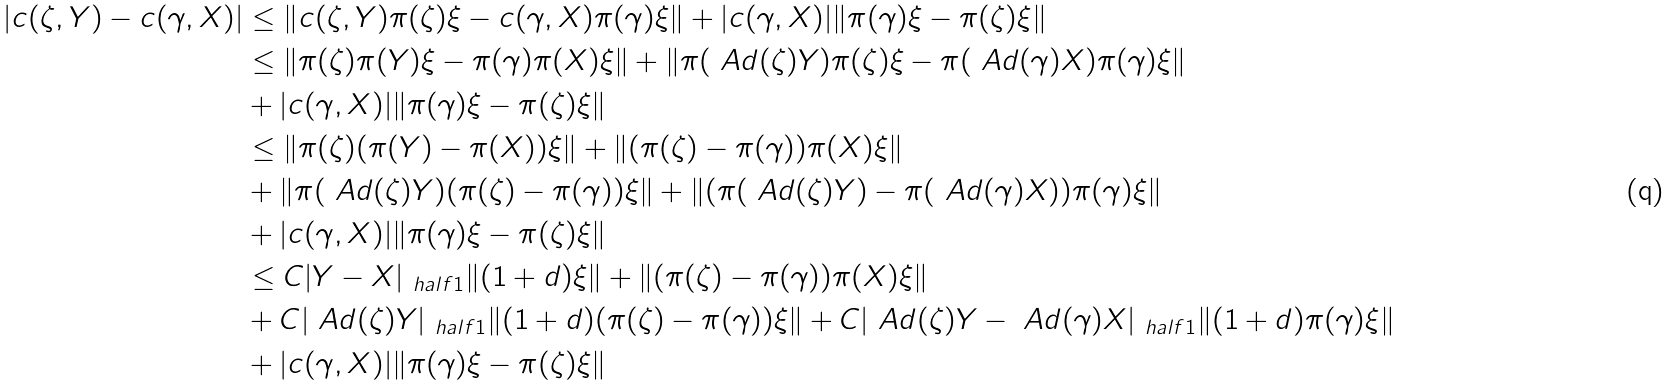<formula> <loc_0><loc_0><loc_500><loc_500>| c ( \zeta , Y ) - c ( \gamma , X ) | & \leq \| c ( \zeta , Y ) \pi ( \zeta ) \xi - c ( \gamma , X ) \pi ( \gamma ) \xi \| + | c ( \gamma , X ) | \| \pi ( \gamma ) \xi - \pi ( \zeta ) \xi \| \\ & \leq \| \pi ( \zeta ) \pi ( Y ) \xi - \pi ( \gamma ) \pi ( X ) \xi \| + \| \pi ( \ A d ( \zeta ) Y ) \pi ( \zeta ) \xi - \pi ( \ A d ( \gamma ) X ) \pi ( \gamma ) \xi \| \\ & + | c ( \gamma , X ) | \| \pi ( \gamma ) \xi - \pi ( \zeta ) \xi \| \\ & \leq \| \pi ( \zeta ) ( \pi ( Y ) - \pi ( X ) ) \xi \| + \| ( \pi ( \zeta ) - \pi ( \gamma ) ) \pi ( X ) \xi \| \\ & + \| \pi ( \ A d ( \zeta ) Y ) ( \pi ( \zeta ) - \pi ( \gamma ) ) \xi \| + \| ( \pi ( \ A d ( \zeta ) Y ) - \pi ( \ A d ( \gamma ) X ) ) \pi ( \gamma ) \xi \| \\ & + | c ( \gamma , X ) | \| \pi ( \gamma ) \xi - \pi ( \zeta ) \xi \| \\ & \leq C | Y - X | _ { \ h a l f { 1 } } \| ( 1 + d ) \xi \| + \| ( \pi ( \zeta ) - \pi ( \gamma ) ) \pi ( X ) \xi \| \\ & + C | \ A d ( \zeta ) Y | _ { \ h a l f { 1 } } \| ( 1 + d ) ( \pi ( \zeta ) - \pi ( \gamma ) ) \xi \| + C | \ A d ( \zeta ) Y - \ A d ( \gamma ) X | _ { \ h a l f { 1 } } \| ( 1 + d ) \pi ( \gamma ) \xi \| \\ & + | c ( \gamma , X ) | \| \pi ( \gamma ) \xi - \pi ( \zeta ) \xi \|</formula> 